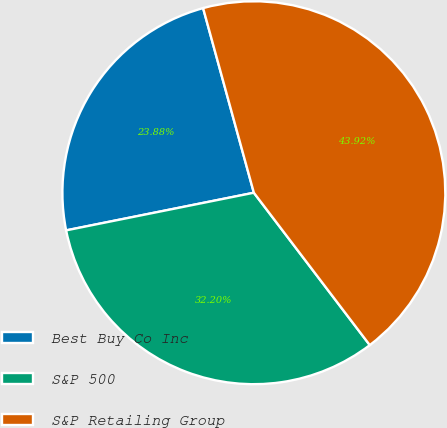<chart> <loc_0><loc_0><loc_500><loc_500><pie_chart><fcel>Best Buy Co Inc<fcel>S&P 500<fcel>S&P Retailing Group<nl><fcel>23.88%<fcel>32.2%<fcel>43.92%<nl></chart> 